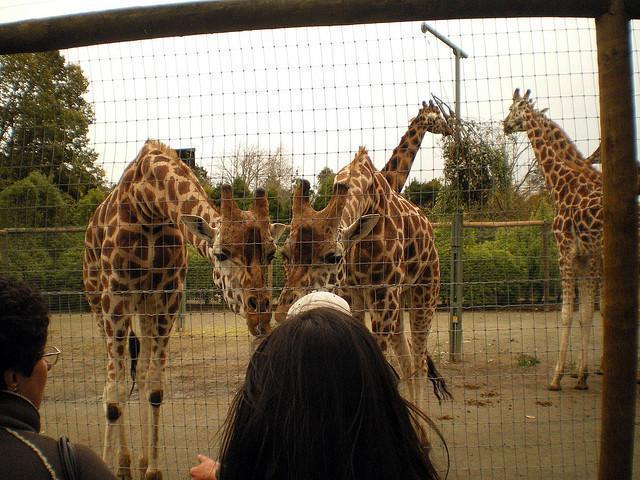What is the person on the left wearing?
From the following four choices, select the correct answer to address the question.
Options: Glasses, fedora, top hat, boa. Glasses. 